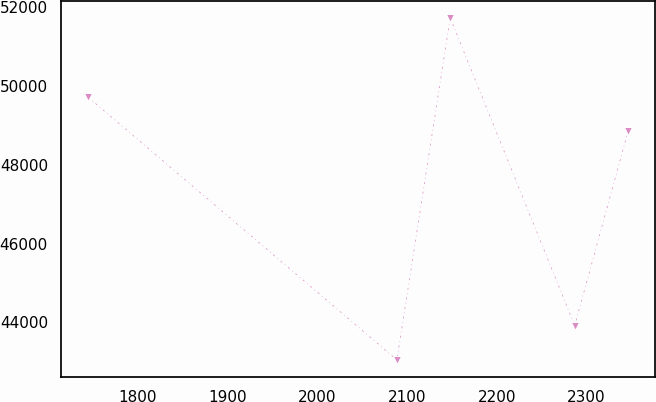<chart> <loc_0><loc_0><loc_500><loc_500><line_chart><ecel><fcel>Unnamed: 1<nl><fcel>1745.23<fcel>49714.7<nl><fcel>2088.94<fcel>43044.2<nl><fcel>2148.24<fcel>51728.4<nl><fcel>2286.82<fcel>43912.6<nl><fcel>2346.12<fcel>48846.3<nl></chart> 